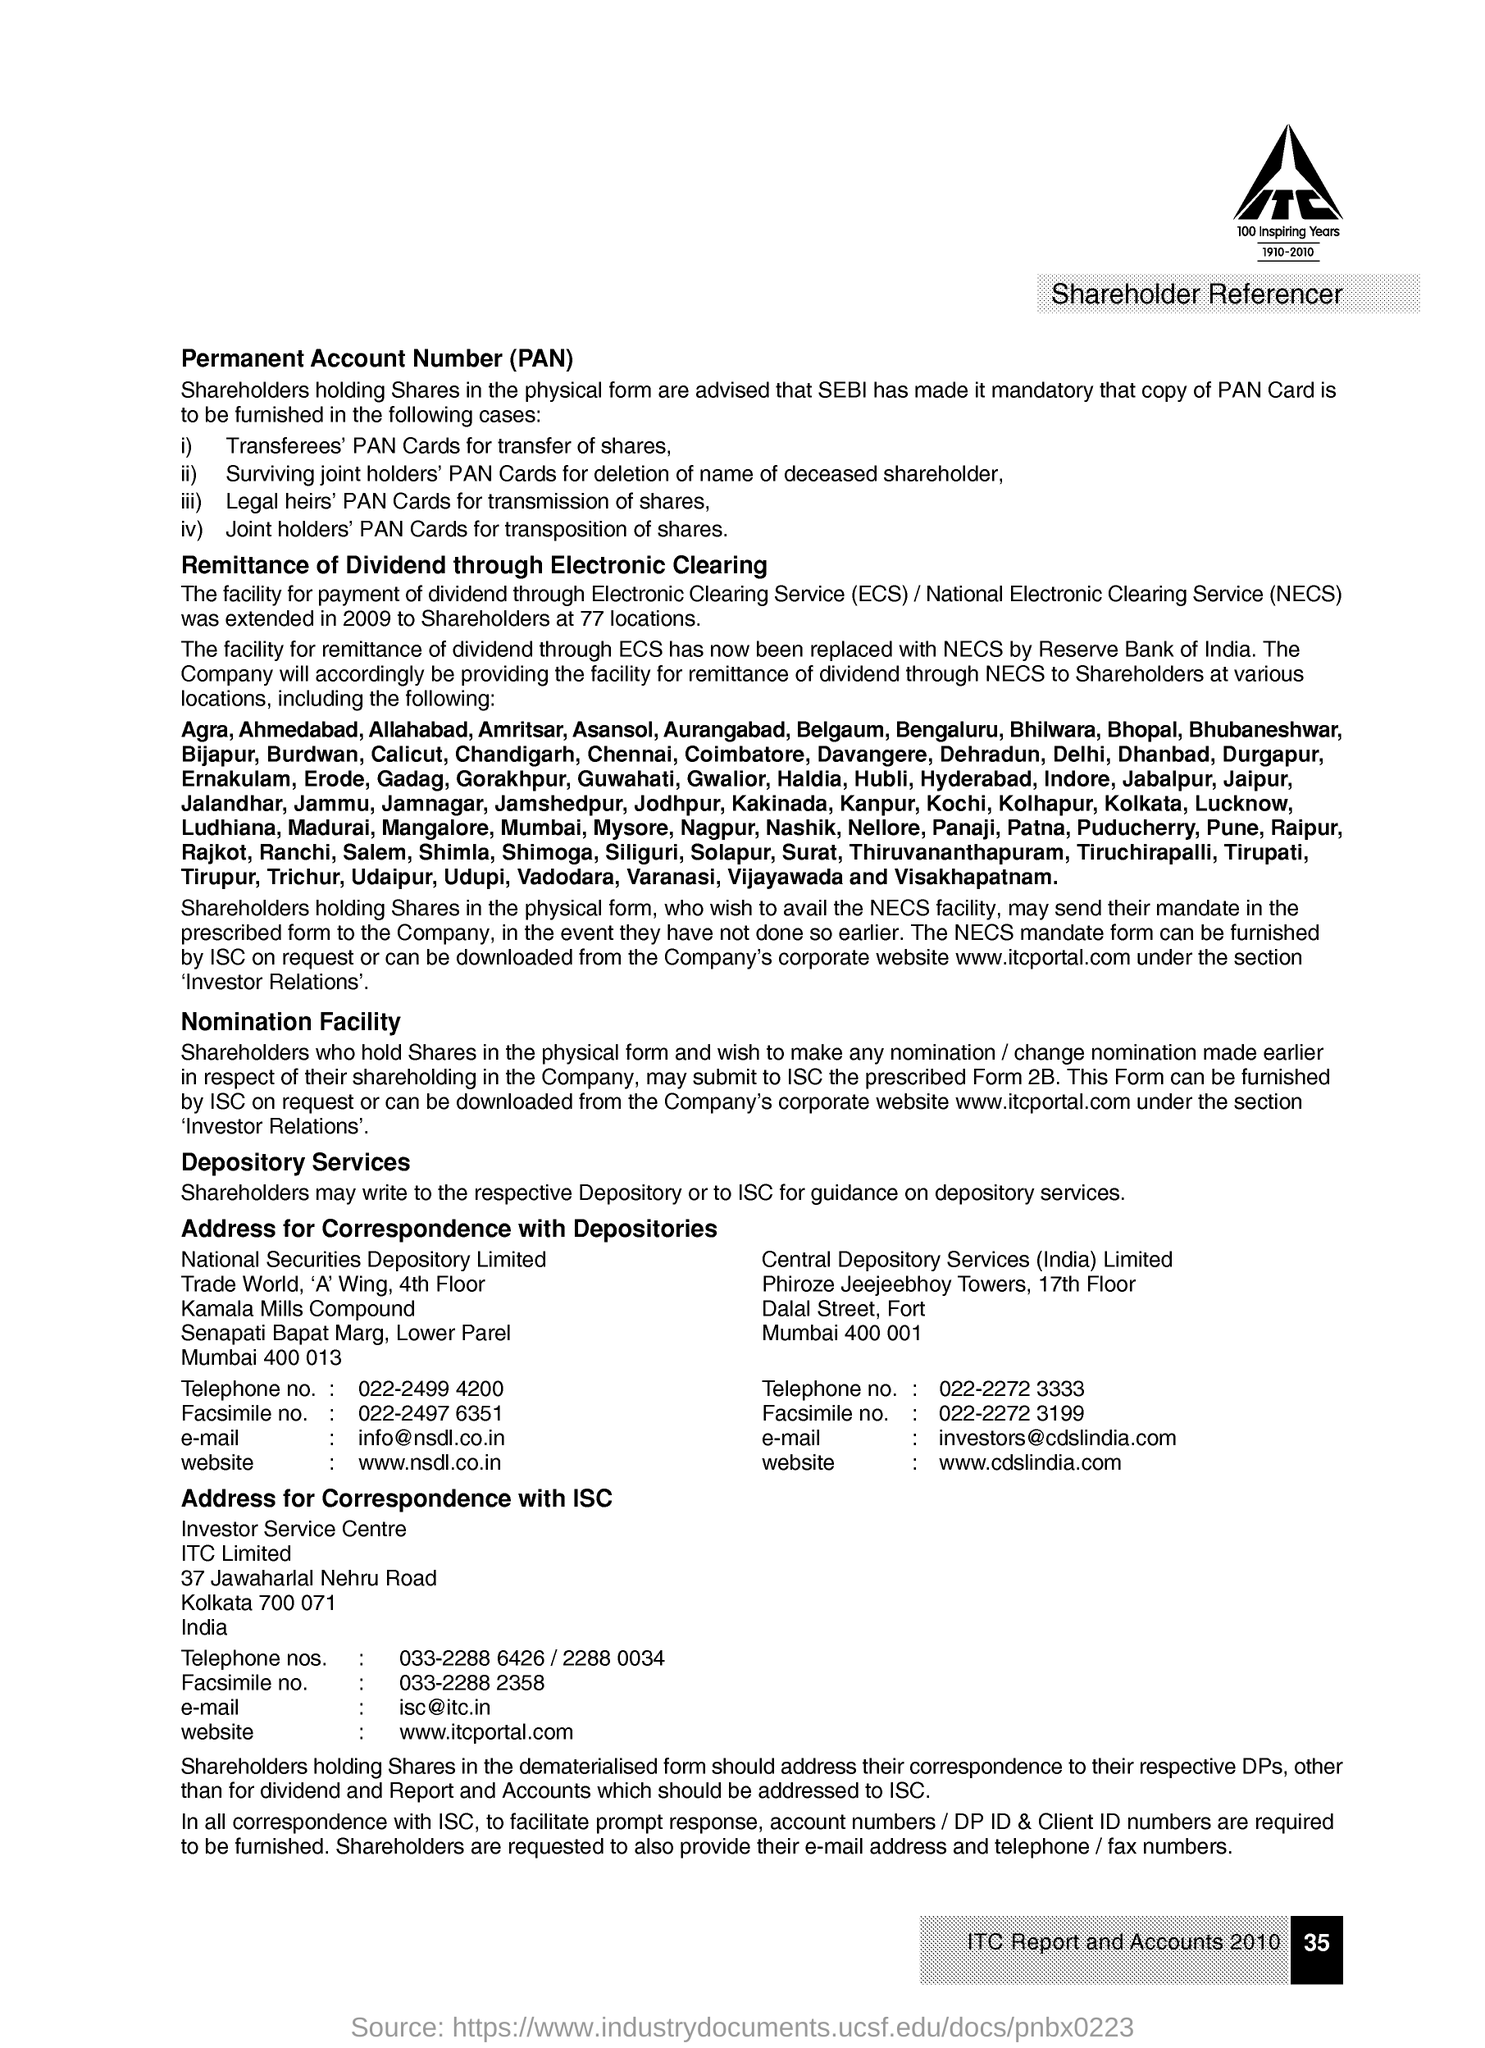What is the short form of Permanent Account Number?
Give a very brief answer. PAN. What is the full form of ECS?
Provide a succinct answer. Electronic Clearing Service. At how many locations is the payment of dividend facility for Shareholders extended?
Offer a terse response. 77. 